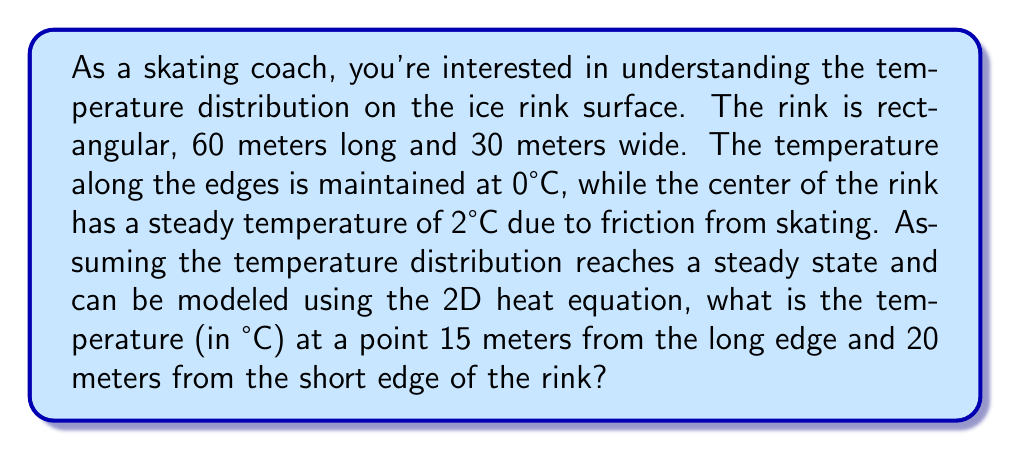Give your solution to this math problem. Let's approach this step-by-step:

1) The 2D steady-state heat equation is given by:

   $$\frac{\partial^2 T}{\partial x^2} + \frac{\partial^2 T}{\partial y^2} = 0$$

2) Given the boundary conditions and the symmetry of the problem, we can model the temperature distribution as:

   $$T(x,y) = T_0 \sin(\frac{\pi x}{L}) \sin(\frac{\pi y}{W})$$

   Where $T_0$ is the maximum temperature (at the center), $L$ is the length, and $W$ is the width of the rink.

3) We know:
   - $L = 60$ m
   - $W = 30$ m
   - $T_0 = 2°C$ (at the center)
   - The point of interest is at $(x,y) = (15,20)$

4) Substituting these values into our equation:

   $$T(15,20) = 2 \sin(\frac{\pi \cdot 15}{60}) \sin(\frac{\pi \cdot 20}{30})$$

5) Simplify:
   $$T(15,20) = 2 \sin(\frac{\pi}{4}) \sin(\frac{2\pi}{3})$$

6) Calculate:
   $$T(15,20) = 2 \cdot 0.7071 \cdot 0.8660 = 1.2247°C$$

7) Rounding to two decimal places: 1.22°C
Answer: 1.22°C 